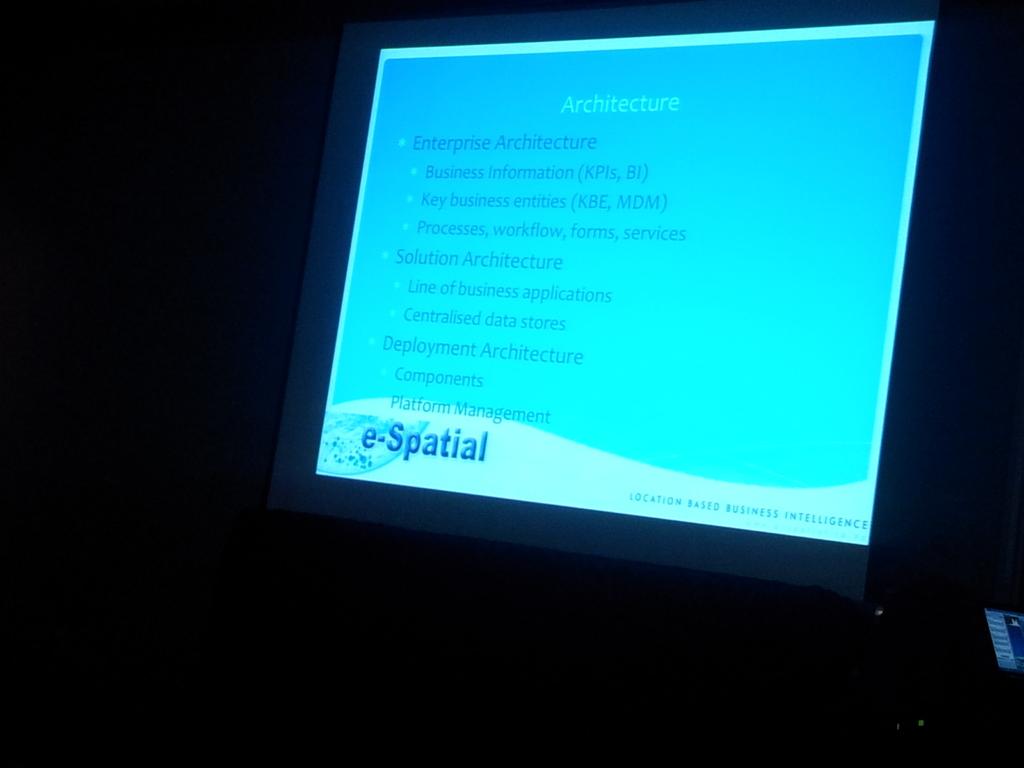What is the slide titled?
Provide a short and direct response. Architecture. What is the first bullet point say?
Provide a short and direct response. Enterprise architecture. 